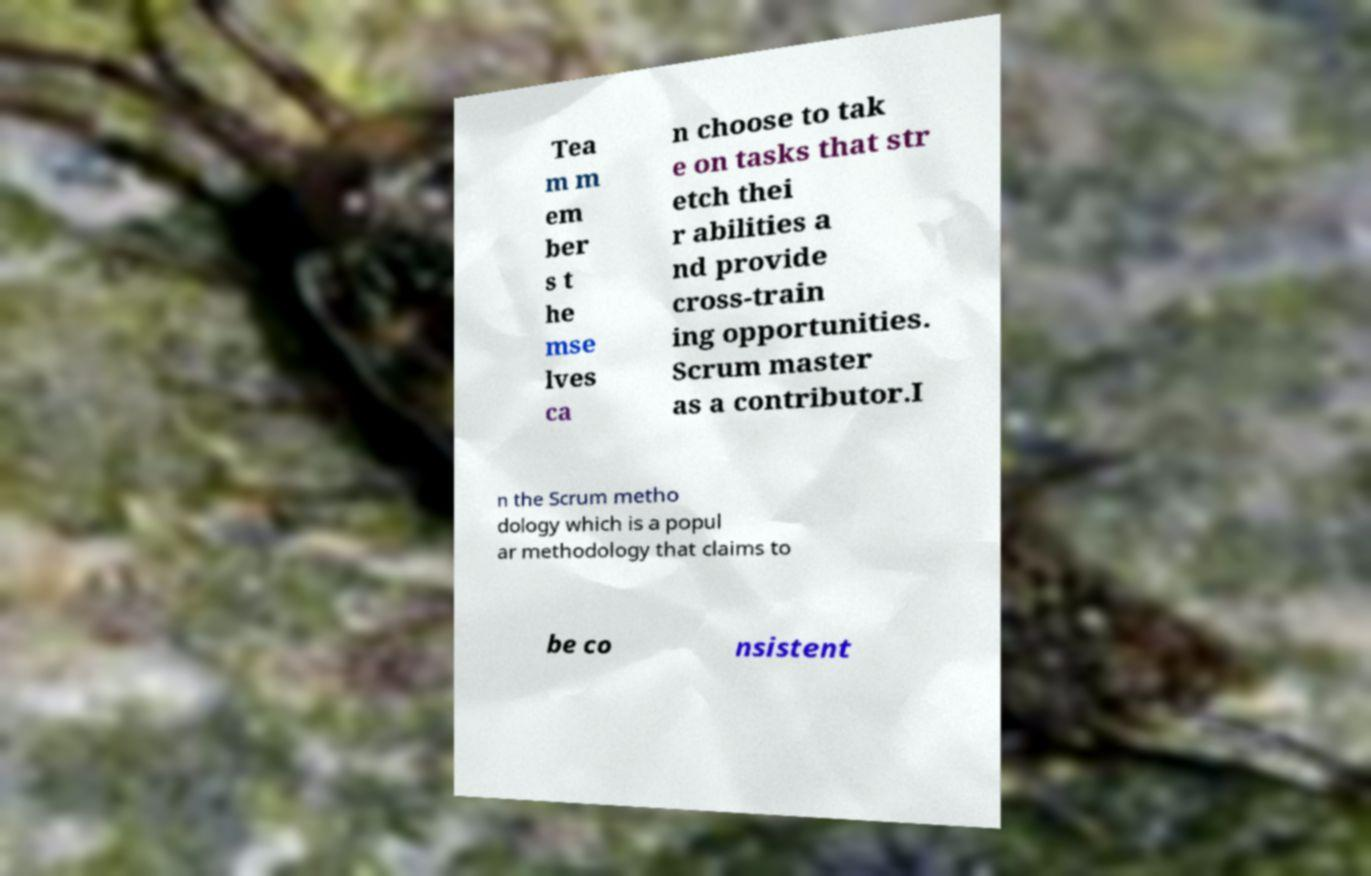What messages or text are displayed in this image? I need them in a readable, typed format. Tea m m em ber s t he mse lves ca n choose to tak e on tasks that str etch thei r abilities a nd provide cross-train ing opportunities. Scrum master as a contributor.I n the Scrum metho dology which is a popul ar methodology that claims to be co nsistent 